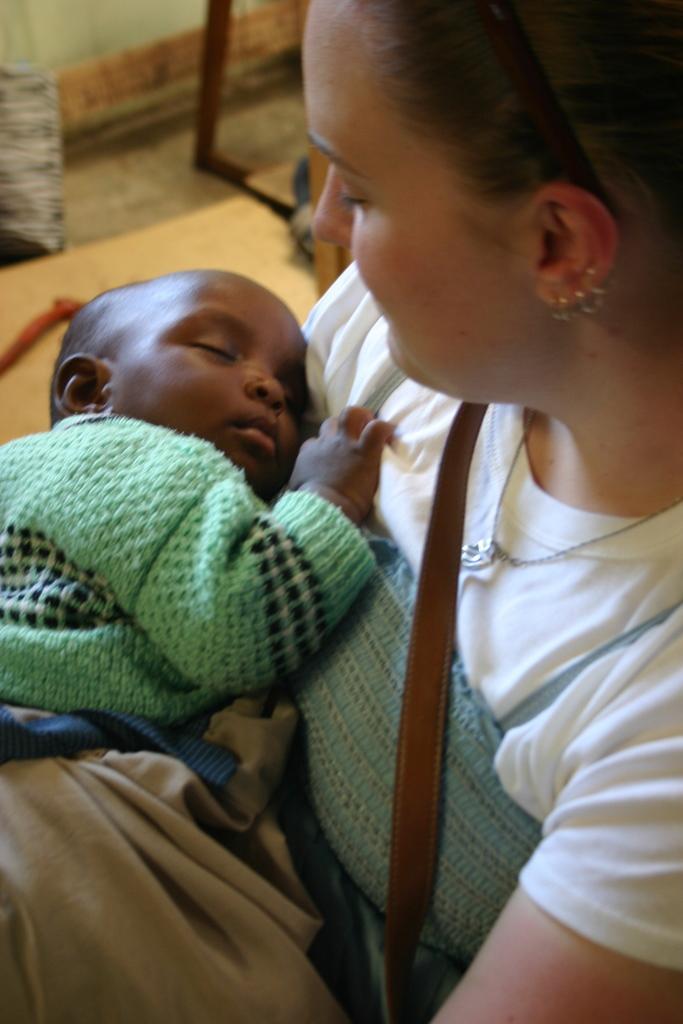Please provide a concise description of this image. In this image we can see two persons. A baby is sleeping in the image. There are few objects on the floor. 